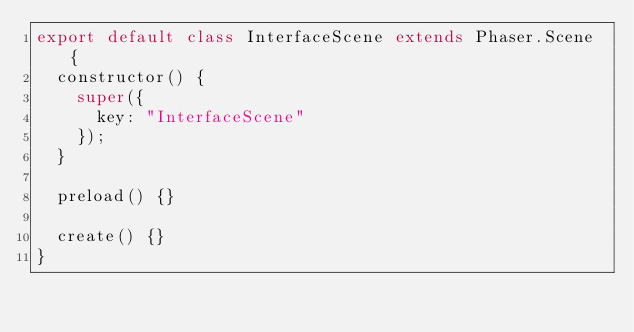<code> <loc_0><loc_0><loc_500><loc_500><_JavaScript_>export default class InterfaceScene extends Phaser.Scene {
	constructor() {
		super({
			key: "InterfaceScene"
		});
	}

	preload() {}

	create() {}
}
</code> 